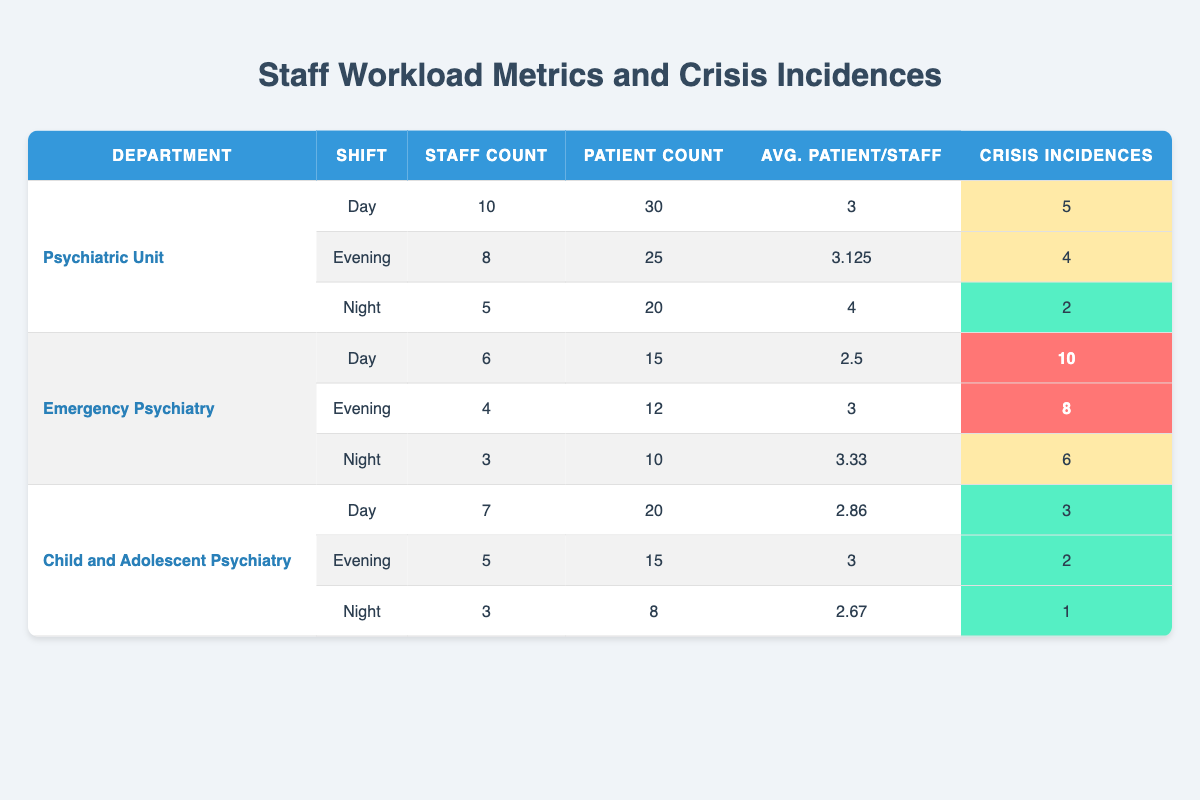What is the average number of patients per staff in the Evening shift for the Psychiatric Unit? For the Psychiatric Unit Evening shift, there are 8 staff members and 25 patients. To find the average number of patients per staff, divide the number of patients by the number of staff: 25 / 8 = 3.125.
Answer: 3.125 Which department has the highest number of crisis incidences during the Day shift? Looking at the Day shift data for all departments, the Emergency Psychiatry department has 10 crisis incidences, which is higher than any other department's Day shift crisis incidences.
Answer: Emergency Psychiatry What is the total crisis incidence count across all shifts for the Child and Adolescent Psychiatry department? Child and Adolescent Psychiatry has 3 crises on the Day shift, 2 on the Evening shift, and 1 on the Night shift. Adding these gives: 3 + 2 + 1 = 6.
Answer: 6 Is it true that the Night shift in the Emergency Psychiatry department has the highest average patients per staff? For the Night shift in Emergency Psychiatry, the average is 3.33 patients per staff. The Night shift for the other departments has averages of 4 (Psychiatric Unit) and 2.67 (Child and Adolescent Psychiatry), meaning Emergency Psychiatry does not have the highest average.
Answer: No What is the average number of crisis incidences per staff in the Day shift across all departments? For the Day shift: Psychiatric Unit has 5 crises with 10 staff (0.5 crises per staff), Emergency Psychiatry has 10 crises with 6 staff (1.67 crises per staff), and Child and Adolescent Psychiatry has 3 crises with 7 staff (0.43 crises per staff). The sum of crises is 5 + 10 + 3 = 18, and the sum of staff is 10 + 6 + 7 = 23, so the average is 18 / 23 ≈ 0.78 crises per staff.
Answer: 0.78 